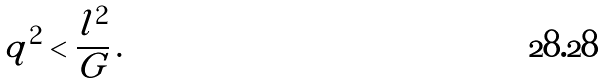<formula> <loc_0><loc_0><loc_500><loc_500>q ^ { 2 } < \frac { l ^ { 2 } } { G } \, .</formula> 